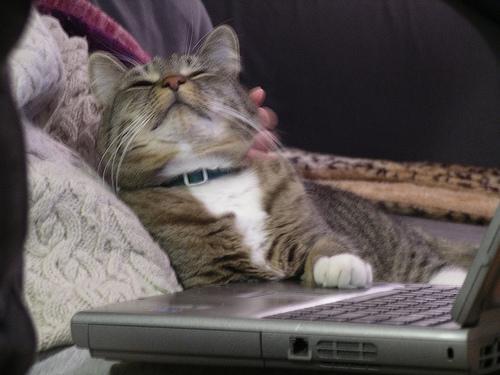How many cats are visible?
Give a very brief answer. 1. How many people can this bike hold?
Give a very brief answer. 0. 